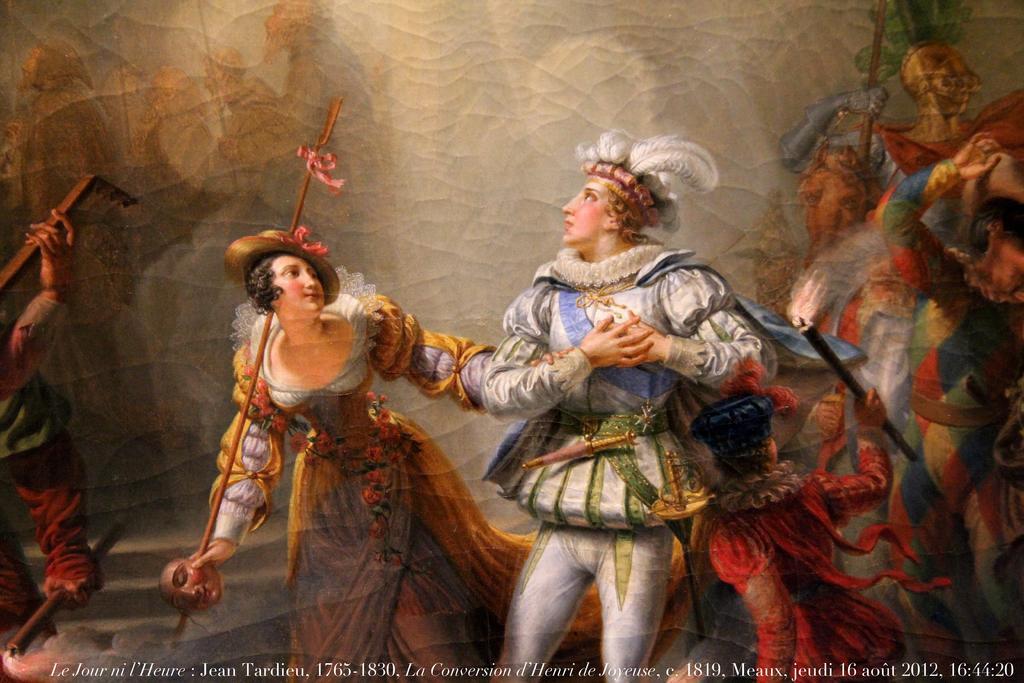Can you describe this image briefly? This image looks like a painting. In the front, there is a man wearing white dress. Beside him, there is a woman holding a stick along with a mask. In the background, there is a wall. 